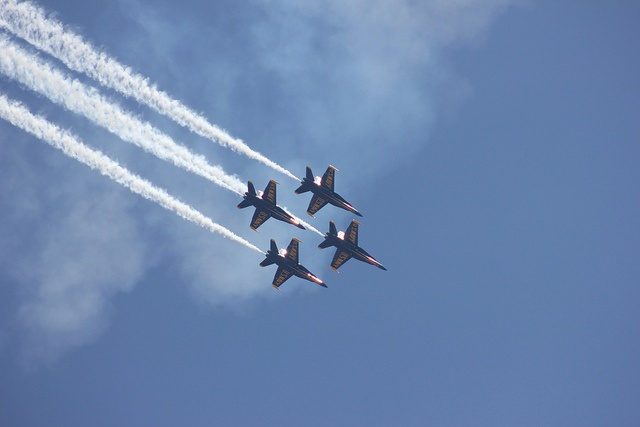Describe the objects in this image and their specific colors. I can see airplane in lightgray, navy, gray, lightblue, and white tones, airplane in lightgray, navy, gray, and darkblue tones, airplane in lightgray, navy, gray, darkblue, and darkgray tones, and airplane in lightgray, navy, gray, and darkblue tones in this image. 